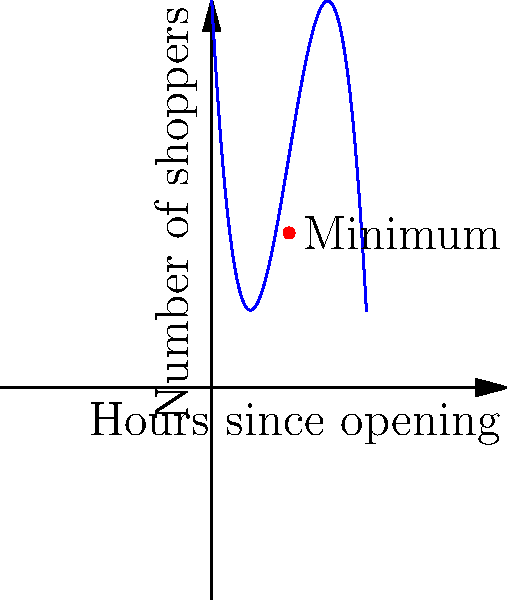The graph shows the number of shoppers in a local grocery store as a function of hours since opening. The function is given by $f(x) = -0.5x^3 + 6x^2 - 18x + 20$, where $x$ is the number of hours since opening and $f(x)$ is the number of shoppers. At what time after opening should you visit the store to encounter the fewest shoppers? To find the time with the fewest shoppers, we need to find the minimum point of the function. This can be done by following these steps:

1) First, we need to find the derivative of the function:
   $f'(x) = -1.5x^2 + 12x - 18$

2) To find the critical points, set $f'(x) = 0$:
   $-1.5x^2 + 12x - 18 = 0$

3) This is a quadratic equation. We can solve it using the quadratic formula:
   $x = \frac{-b \pm \sqrt{b^2 - 4ac}}{2a}$

   Where $a = -1.5$, $b = 12$, and $c = -18$

4) Plugging in these values:
   $x = \frac{-12 \pm \sqrt{12^2 - 4(-1.5)(-18)}}{2(-1.5)}$
   $= \frac{-12 \pm \sqrt{144 - 108}}{-3}$
   $= \frac{-12 \pm \sqrt{36}}{-3}$
   $= \frac{-12 \pm 6}{-3}$

5) This gives us two solutions:
   $x = \frac{-12 + 6}{-3} = 2$ or $x = \frac{-12 - 6}{-3} = 6$

6) To determine which of these is the minimum, we can check the second derivative:
   $f''(x) = -3x + 12$

   At $x = 2$: $f''(2) = -3(2) + 12 = 6 > 0$, so this is a minimum.
   At $x = 6$: $f''(6) = -3(6) + 12 = -6 < 0$, so this is a maximum.

Therefore, the minimum occurs at $x = 2$, which means 2 hours after opening.
Answer: 2 hours after opening 